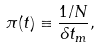Convert formula to latex. <formula><loc_0><loc_0><loc_500><loc_500>\pi ( t ) \equiv \frac { 1 / N } { \delta t _ { m } } ,</formula> 